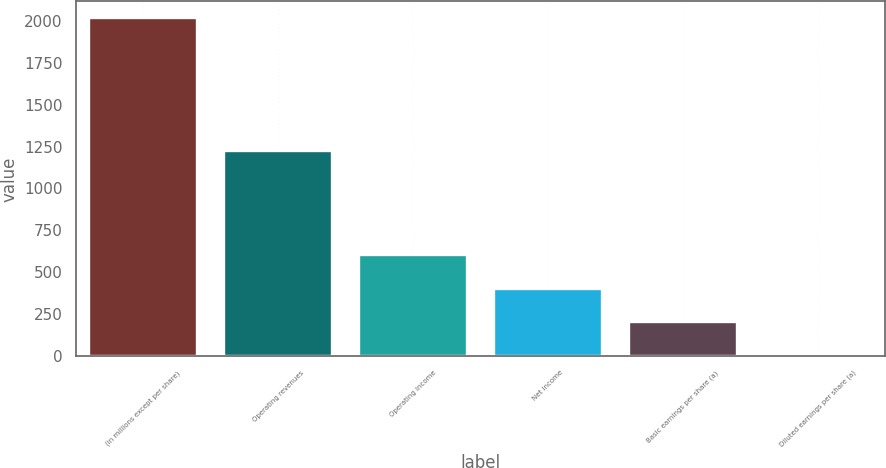Convert chart. <chart><loc_0><loc_0><loc_500><loc_500><bar_chart><fcel>(in millions except per share)<fcel>Operating revenues<fcel>Operating income<fcel>Net income<fcel>Basic earnings per share (a)<fcel>Diluted earnings per share (a)<nl><fcel>2014<fcel>1222<fcel>604.67<fcel>403.34<fcel>202.01<fcel>0.68<nl></chart> 